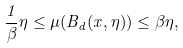Convert formula to latex. <formula><loc_0><loc_0><loc_500><loc_500>\frac { 1 } { \beta } \eta \leq \mu ( B _ { d } ( x , \eta ) ) \leq \beta \eta ,</formula> 